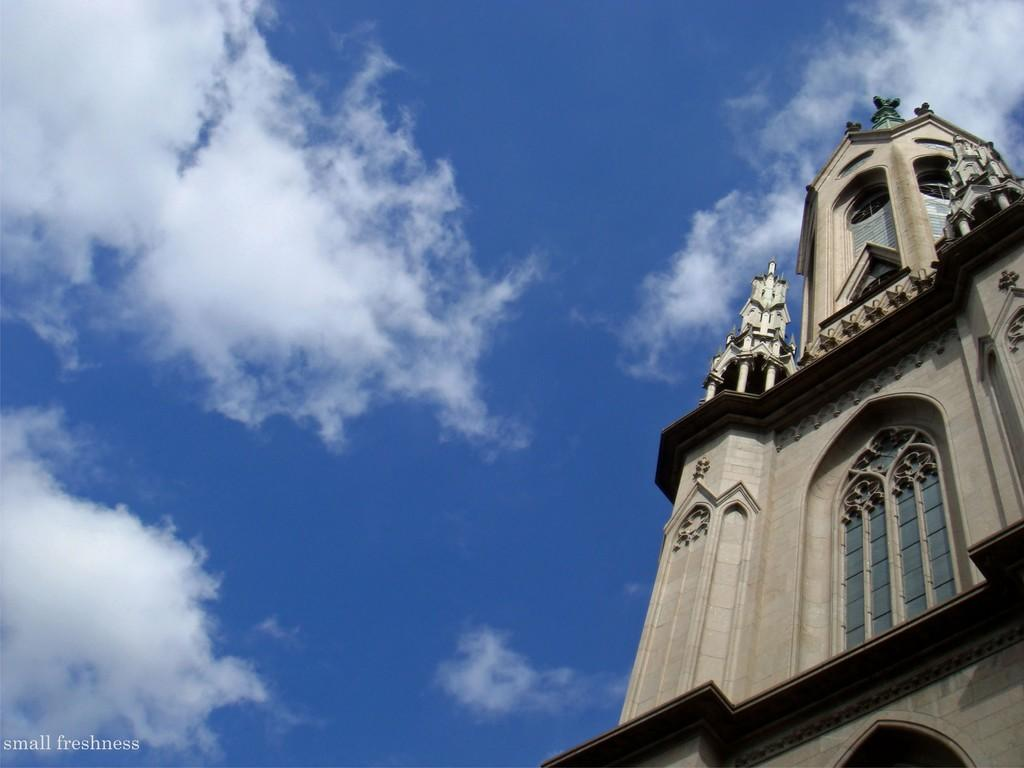What structure is located on the right side of the image? There is a tower on the right side of the image. What is visible in the background of the image? The sky is visible in the background of the image. What type of bait is being used by the judge in the image? There is no judge or bait present in the image; it features a tower and the sky. 